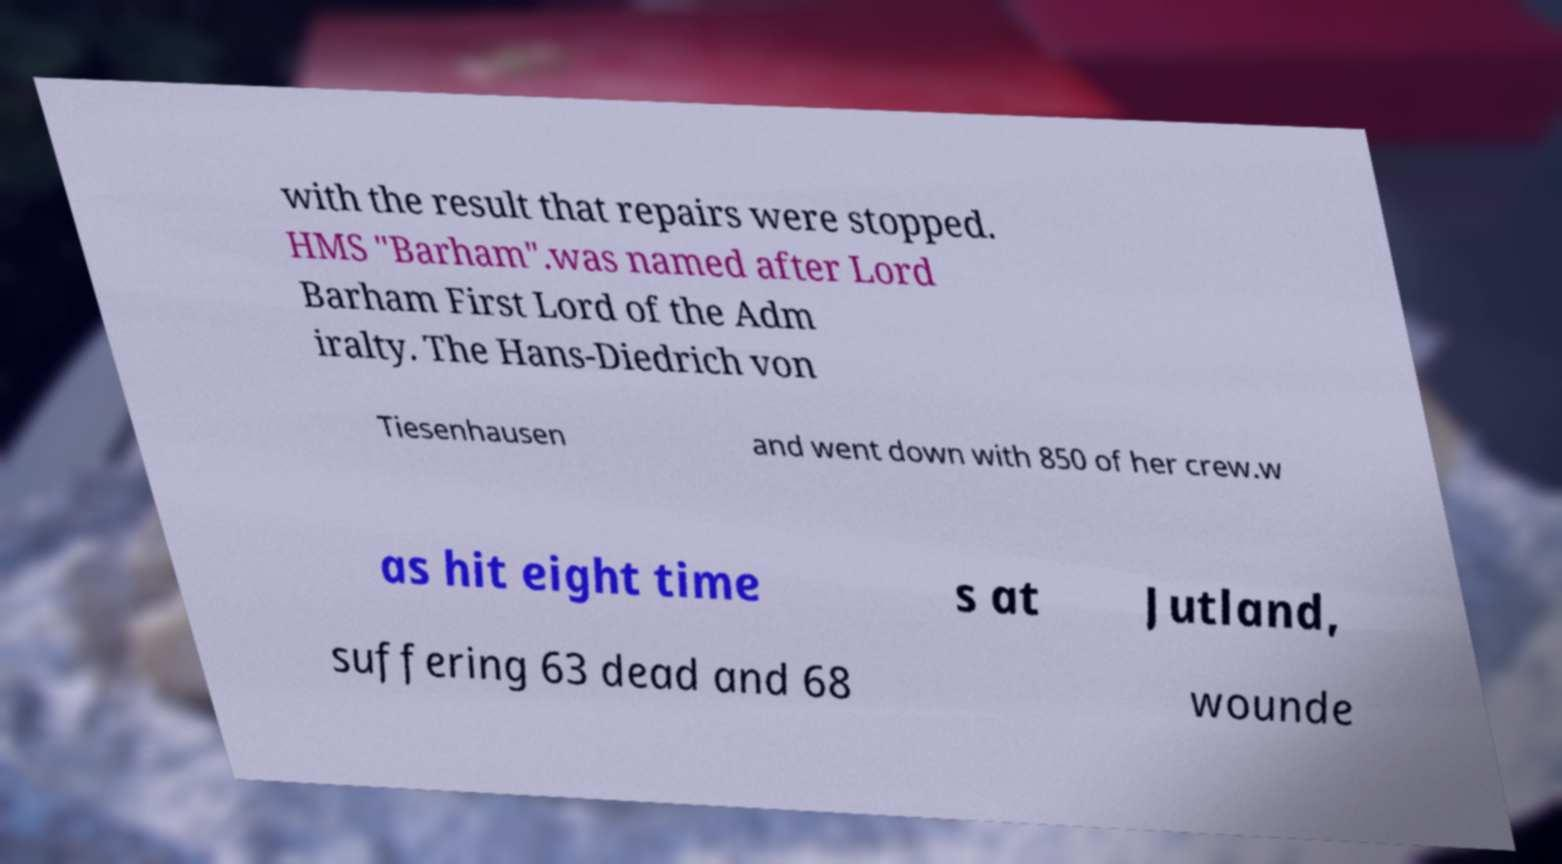I need the written content from this picture converted into text. Can you do that? with the result that repairs were stopped. HMS "Barham".was named after Lord Barham First Lord of the Adm iralty. The Hans-Diedrich von Tiesenhausen and went down with 850 of her crew.w as hit eight time s at Jutland, suffering 63 dead and 68 wounde 